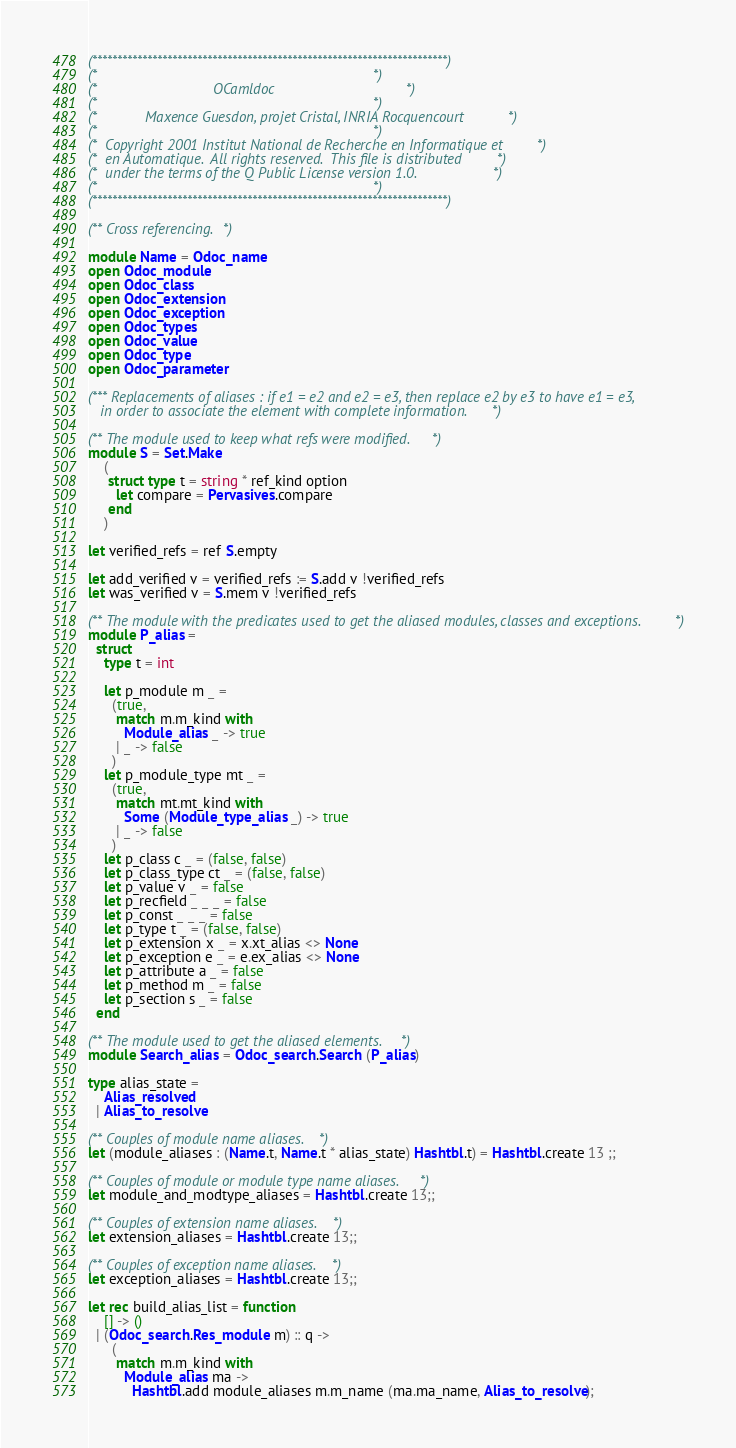Convert code to text. <code><loc_0><loc_0><loc_500><loc_500><_OCaml_>(***********************************************************************)
(*                                                                     *)
(*                             OCamldoc                                *)
(*                                                                     *)
(*            Maxence Guesdon, projet Cristal, INRIA Rocquencourt      *)
(*                                                                     *)
(*  Copyright 2001 Institut National de Recherche en Informatique et   *)
(*  en Automatique.  All rights reserved.  This file is distributed    *)
(*  under the terms of the Q Public License version 1.0.               *)
(*                                                                     *)
(***********************************************************************)

(** Cross referencing. *)

module Name = Odoc_name
open Odoc_module
open Odoc_class
open Odoc_extension
open Odoc_exception
open Odoc_types
open Odoc_value
open Odoc_type
open Odoc_parameter

(*** Replacements of aliases : if e1 = e2 and e2 = e3, then replace e2 by e3 to have e1 = e3,
   in order to associate the element with complete information. *)

(** The module used to keep what refs were modified. *)
module S = Set.Make
    (
     struct type t = string * ref_kind option
       let compare = Pervasives.compare
     end
    )

let verified_refs = ref S.empty

let add_verified v = verified_refs := S.add v !verified_refs
let was_verified v = S.mem v !verified_refs

(** The module with the predicates used to get the aliased modules, classes and exceptions. *)
module P_alias =
  struct
    type t = int

    let p_module m _ =
      (true,
       match m.m_kind with
         Module_alias _ -> true
       | _ -> false
      )
    let p_module_type mt _ =
      (true,
       match mt.mt_kind with
         Some (Module_type_alias _) -> true
       | _ -> false
      )
    let p_class c _ = (false, false)
    let p_class_type ct _ = (false, false)
    let p_value v _ = false
    let p_recfield _ _ _ = false
    let p_const _ _ _ = false
    let p_type t _ = (false, false)
    let p_extension x _ = x.xt_alias <> None
    let p_exception e _ = e.ex_alias <> None
    let p_attribute a _ = false
    let p_method m _ = false
    let p_section s _ = false
  end

(** The module used to get the aliased elements. *)
module Search_alias = Odoc_search.Search (P_alias)

type alias_state =
    Alias_resolved
  | Alias_to_resolve

(** Couples of module name aliases. *)
let (module_aliases : (Name.t, Name.t * alias_state) Hashtbl.t) = Hashtbl.create 13 ;;

(** Couples of module or module type name aliases. *)
let module_and_modtype_aliases = Hashtbl.create 13;;

(** Couples of extension name aliases. *)
let extension_aliases = Hashtbl.create 13;;

(** Couples of exception name aliases. *)
let exception_aliases = Hashtbl.create 13;;

let rec build_alias_list = function
    [] -> ()
  | (Odoc_search.Res_module m) :: q ->
      (
       match m.m_kind with
         Module_alias ma ->
           Hashtbl.add module_aliases m.m_name (ma.ma_name, Alias_to_resolve);</code> 